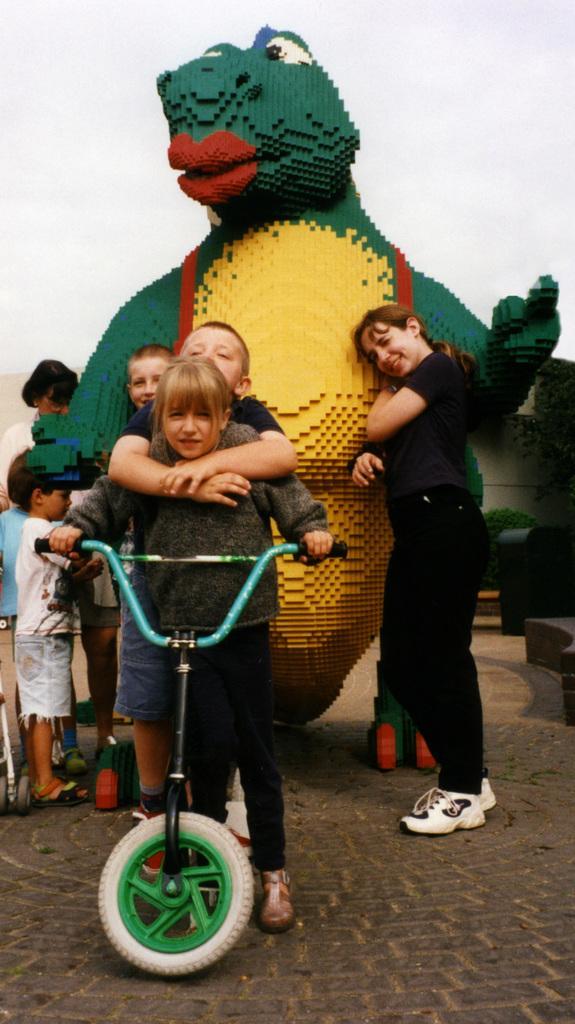Can you describe this image briefly? This image is taken outdoors. At the bottom of the image there is a floor. At the top of the image there is a sky clouds. In the middle of the image there is a dragon and two women and kids are standing on the floor. In the middle of the image three kids are holding a bicycle. 